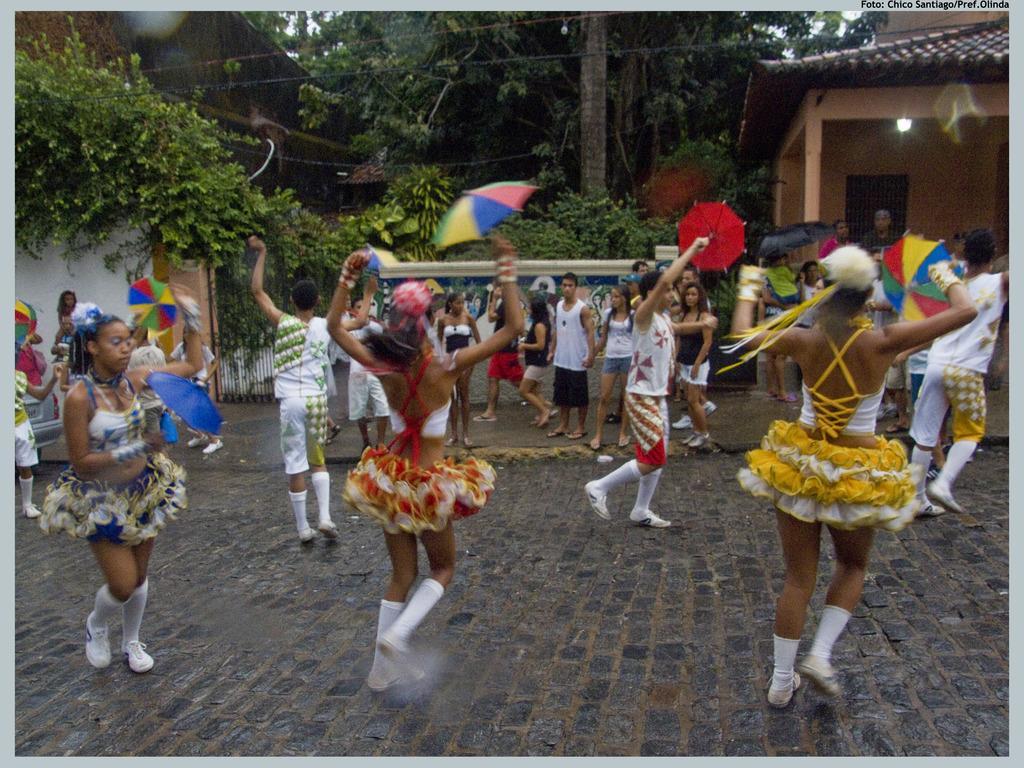How would you summarize this image in a sentence or two? In the picture we can see a some women and men are dancing on the path and behind some people are watching them and in the background, we can see some plants, trees and a house with a light to the ceiling of a house. 